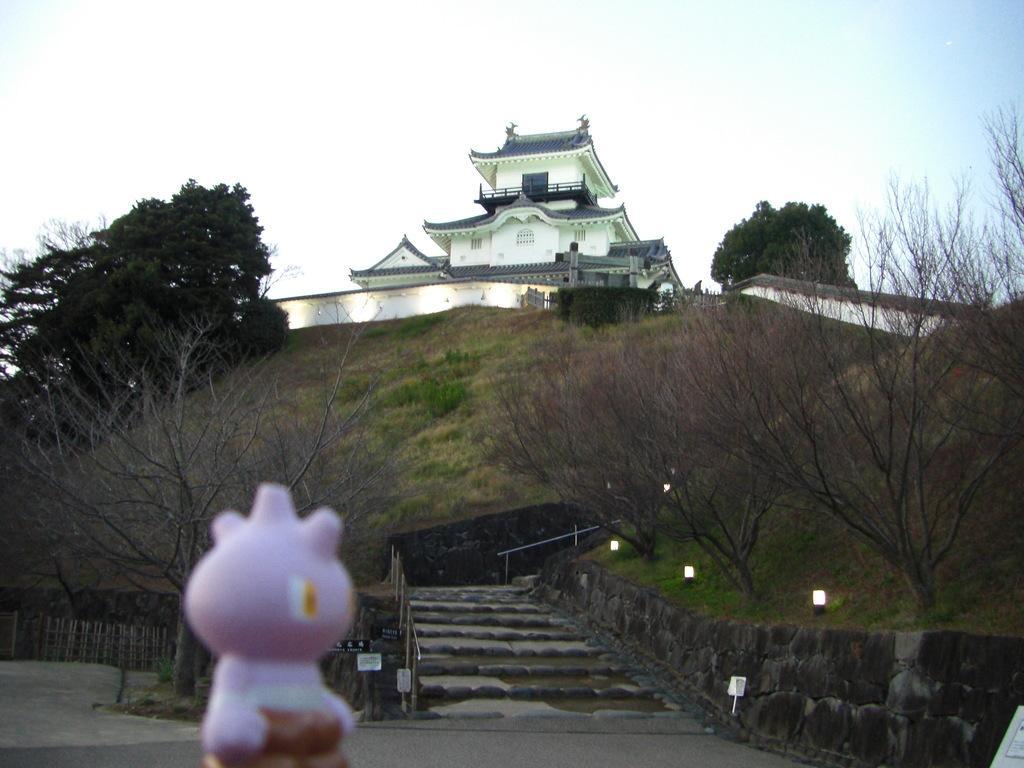How would you summarize this image in a sentence or two? In this image I can see building trees ,grass , and staircase , wall ,lights and at the top I can see the sky and at bottom I can see toy and road. 